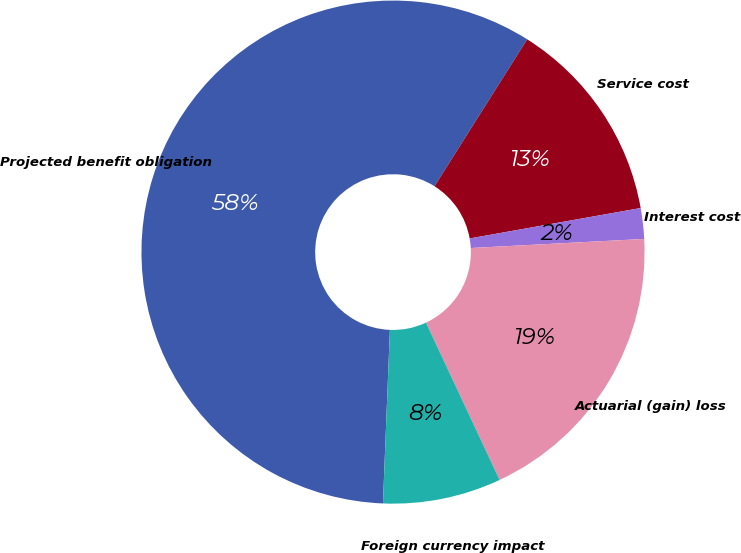<chart> <loc_0><loc_0><loc_500><loc_500><pie_chart><fcel>Projected benefit obligation<fcel>Service cost<fcel>Interest cost<fcel>Actuarial (gain) loss<fcel>Foreign currency impact<nl><fcel>58.32%<fcel>13.24%<fcel>1.97%<fcel>18.87%<fcel>7.6%<nl></chart> 